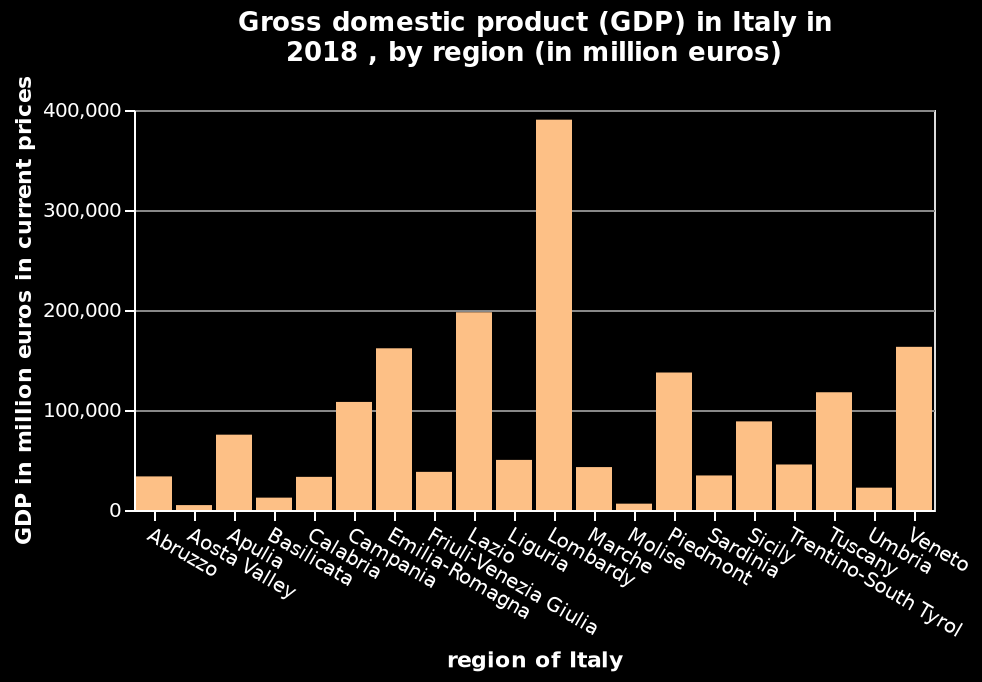<image>
Which region has the highest GDP output?  Lombardy has the highest GDP output. What does the x-axis of the bar diagram represent?  The x-axis represents the region of Italy. please summary the statistics and relations of the chart There is a huge difference between the different regions and their GDP output, the highest beinf nearly 400,000 million euros in Lombardy and the lowest being around 5 million in the Asota Valley. What is the unit of measurement for the GDP values on the y-axis? The unit of measurement for the GDP values on the y-axis is million euros. 